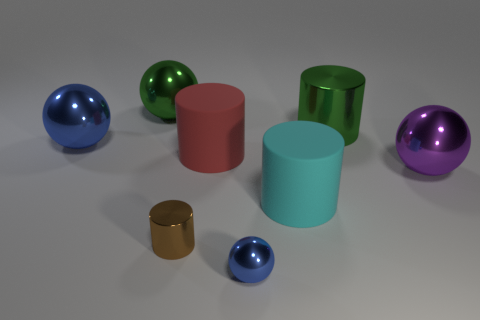What size is the cylinder that is both on the right side of the small blue shiny ball and on the left side of the green cylinder?
Provide a succinct answer. Large. What number of rubber things are either purple balls or small cubes?
Give a very brief answer. 0. What is the purple sphere made of?
Ensure brevity in your answer.  Metal. What is the material of the large cylinder that is on the left side of the blue metallic object that is in front of the metallic cylinder in front of the big red thing?
Your answer should be compact. Rubber. The cyan rubber thing that is the same size as the purple ball is what shape?
Offer a very short reply. Cylinder. How many things are green rubber balls or large metallic balls that are behind the purple metal sphere?
Provide a succinct answer. 2. Are the large cyan thing in front of the red rubber thing and the blue ball that is in front of the small metal cylinder made of the same material?
Ensure brevity in your answer.  No. There is a big metal object that is the same color as the small sphere; what is its shape?
Keep it short and to the point. Sphere. How many yellow objects are either small metal things or big objects?
Give a very brief answer. 0. The cyan cylinder is what size?
Give a very brief answer. Large. 